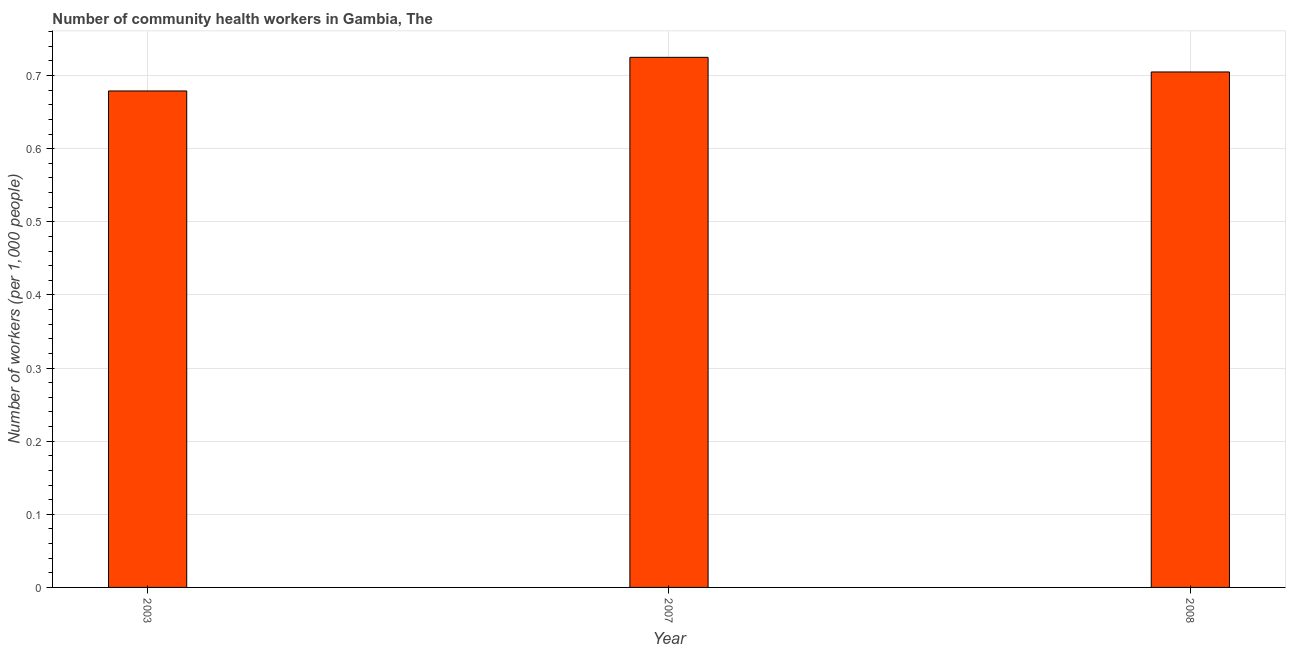Does the graph contain any zero values?
Offer a very short reply. No. Does the graph contain grids?
Your answer should be compact. Yes. What is the title of the graph?
Give a very brief answer. Number of community health workers in Gambia, The. What is the label or title of the X-axis?
Keep it short and to the point. Year. What is the label or title of the Y-axis?
Offer a terse response. Number of workers (per 1,0 people). What is the number of community health workers in 2007?
Your answer should be very brief. 0.72. Across all years, what is the maximum number of community health workers?
Provide a short and direct response. 0.72. Across all years, what is the minimum number of community health workers?
Your answer should be compact. 0.68. What is the sum of the number of community health workers?
Make the answer very short. 2.11. What is the difference between the number of community health workers in 2003 and 2007?
Keep it short and to the point. -0.05. What is the average number of community health workers per year?
Ensure brevity in your answer.  0.7. What is the median number of community health workers?
Offer a terse response. 0.7. In how many years, is the number of community health workers greater than 0.58 ?
Offer a very short reply. 3. Do a majority of the years between 2003 and 2007 (inclusive) have number of community health workers greater than 0.54 ?
Ensure brevity in your answer.  Yes. What is the ratio of the number of community health workers in 2003 to that in 2007?
Offer a terse response. 0.94. Is the number of community health workers in 2003 less than that in 2007?
Offer a terse response. Yes. Is the sum of the number of community health workers in 2007 and 2008 greater than the maximum number of community health workers across all years?
Make the answer very short. Yes. What is the difference between the highest and the lowest number of community health workers?
Keep it short and to the point. 0.05. In how many years, is the number of community health workers greater than the average number of community health workers taken over all years?
Offer a very short reply. 2. How many bars are there?
Provide a short and direct response. 3. Are all the bars in the graph horizontal?
Give a very brief answer. No. How many years are there in the graph?
Keep it short and to the point. 3. Are the values on the major ticks of Y-axis written in scientific E-notation?
Your answer should be compact. No. What is the Number of workers (per 1,000 people) in 2003?
Ensure brevity in your answer.  0.68. What is the Number of workers (per 1,000 people) in 2007?
Your response must be concise. 0.72. What is the Number of workers (per 1,000 people) in 2008?
Provide a succinct answer. 0.7. What is the difference between the Number of workers (per 1,000 people) in 2003 and 2007?
Make the answer very short. -0.05. What is the difference between the Number of workers (per 1,000 people) in 2003 and 2008?
Provide a succinct answer. -0.03. What is the difference between the Number of workers (per 1,000 people) in 2007 and 2008?
Give a very brief answer. 0.02. What is the ratio of the Number of workers (per 1,000 people) in 2003 to that in 2007?
Your answer should be very brief. 0.94. What is the ratio of the Number of workers (per 1,000 people) in 2007 to that in 2008?
Provide a short and direct response. 1.03. 